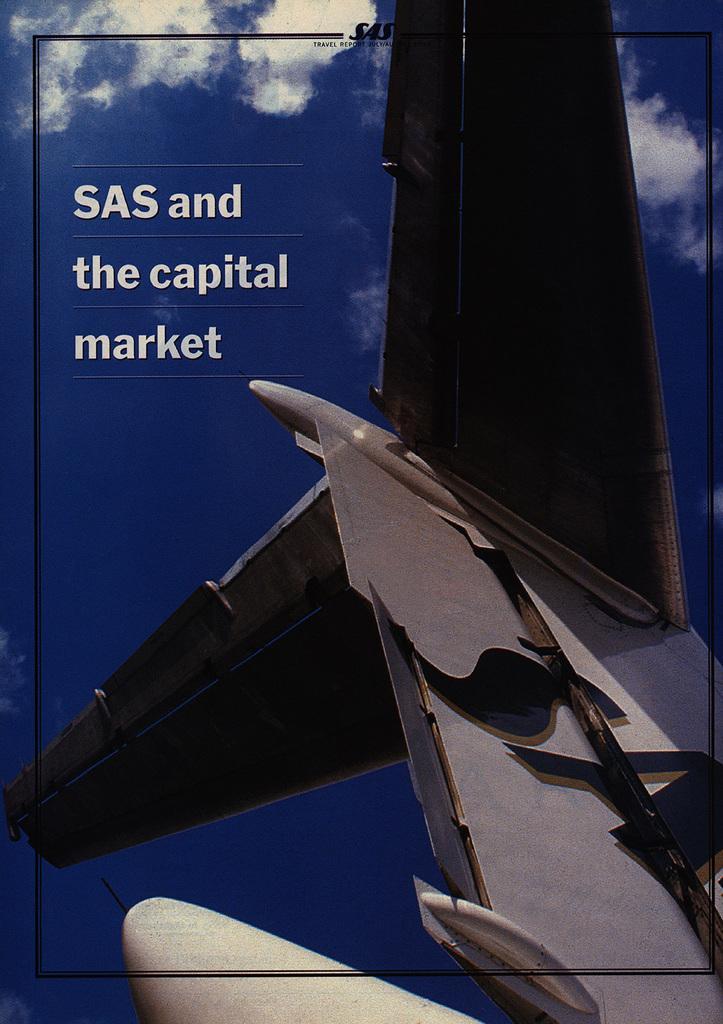Could you give a brief overview of what you see in this image? It is an edited image. In the center of the image we can see one airplane and some text. And we can see a black color line around the image. In the background we can see the sky and clouds. 